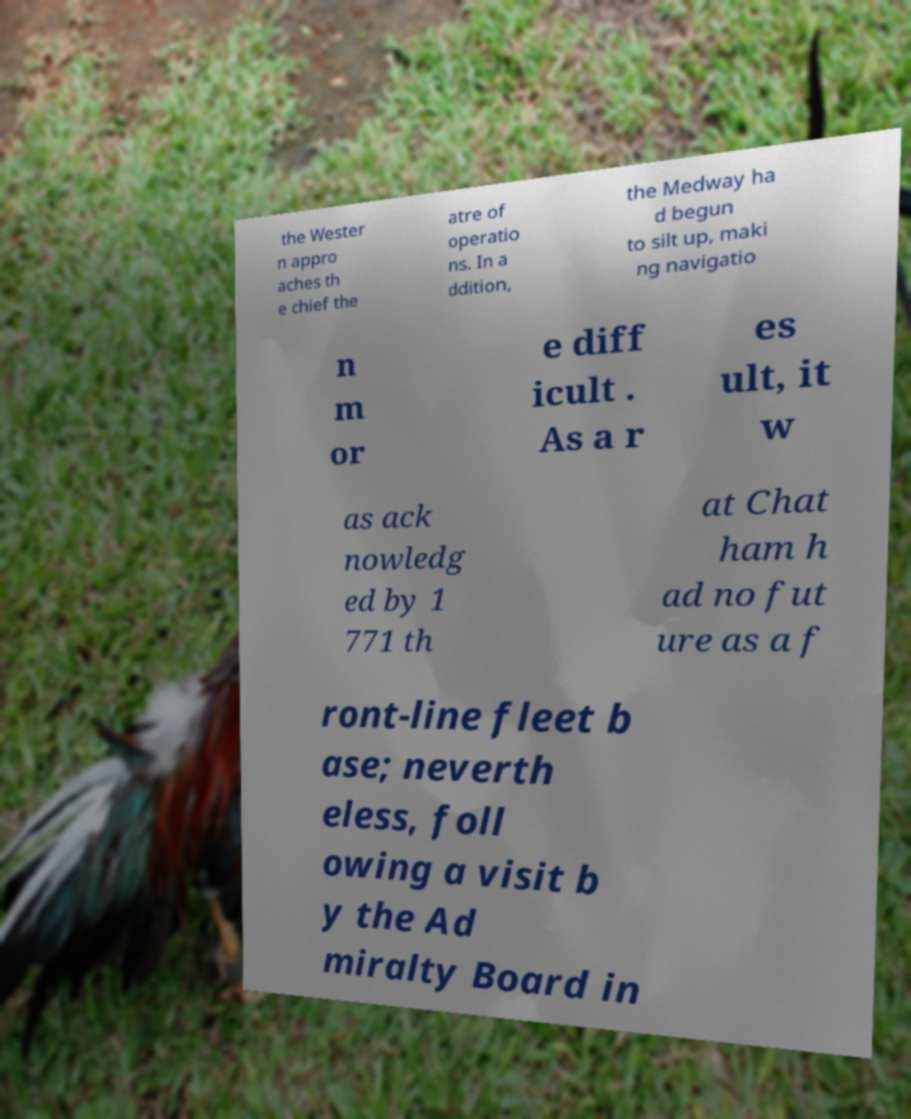What messages or text are displayed in this image? I need them in a readable, typed format. the Wester n appro aches th e chief the atre of operatio ns. In a ddition, the Medway ha d begun to silt up, maki ng navigatio n m or e diff icult . As a r es ult, it w as ack nowledg ed by 1 771 th at Chat ham h ad no fut ure as a f ront-line fleet b ase; neverth eless, foll owing a visit b y the Ad miralty Board in 